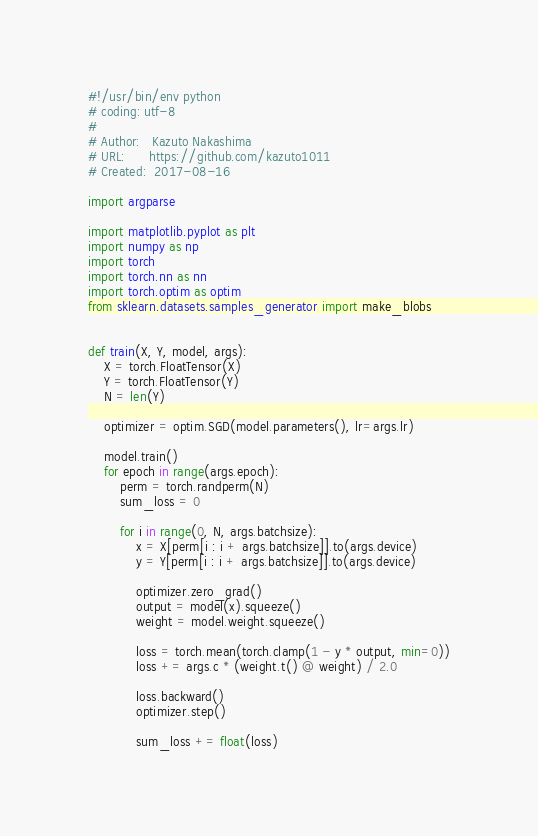Convert code to text. <code><loc_0><loc_0><loc_500><loc_500><_Python_>#!/usr/bin/env python
# coding: utf-8
#
# Author:   Kazuto Nakashima
# URL:      https://github.com/kazuto1011
# Created:  2017-08-16

import argparse

import matplotlib.pyplot as plt
import numpy as np
import torch
import torch.nn as nn
import torch.optim as optim
from sklearn.datasets.samples_generator import make_blobs


def train(X, Y, model, args):
    X = torch.FloatTensor(X)
    Y = torch.FloatTensor(Y)
    N = len(Y)

    optimizer = optim.SGD(model.parameters(), lr=args.lr)

    model.train()
    for epoch in range(args.epoch):
        perm = torch.randperm(N)
        sum_loss = 0

        for i in range(0, N, args.batchsize):
            x = X[perm[i : i + args.batchsize]].to(args.device)
            y = Y[perm[i : i + args.batchsize]].to(args.device)

            optimizer.zero_grad()
            output = model(x).squeeze()
            weight = model.weight.squeeze()

            loss = torch.mean(torch.clamp(1 - y * output, min=0))
            loss += args.c * (weight.t() @ weight) / 2.0

            loss.backward()
            optimizer.step()

            sum_loss += float(loss)
</code> 